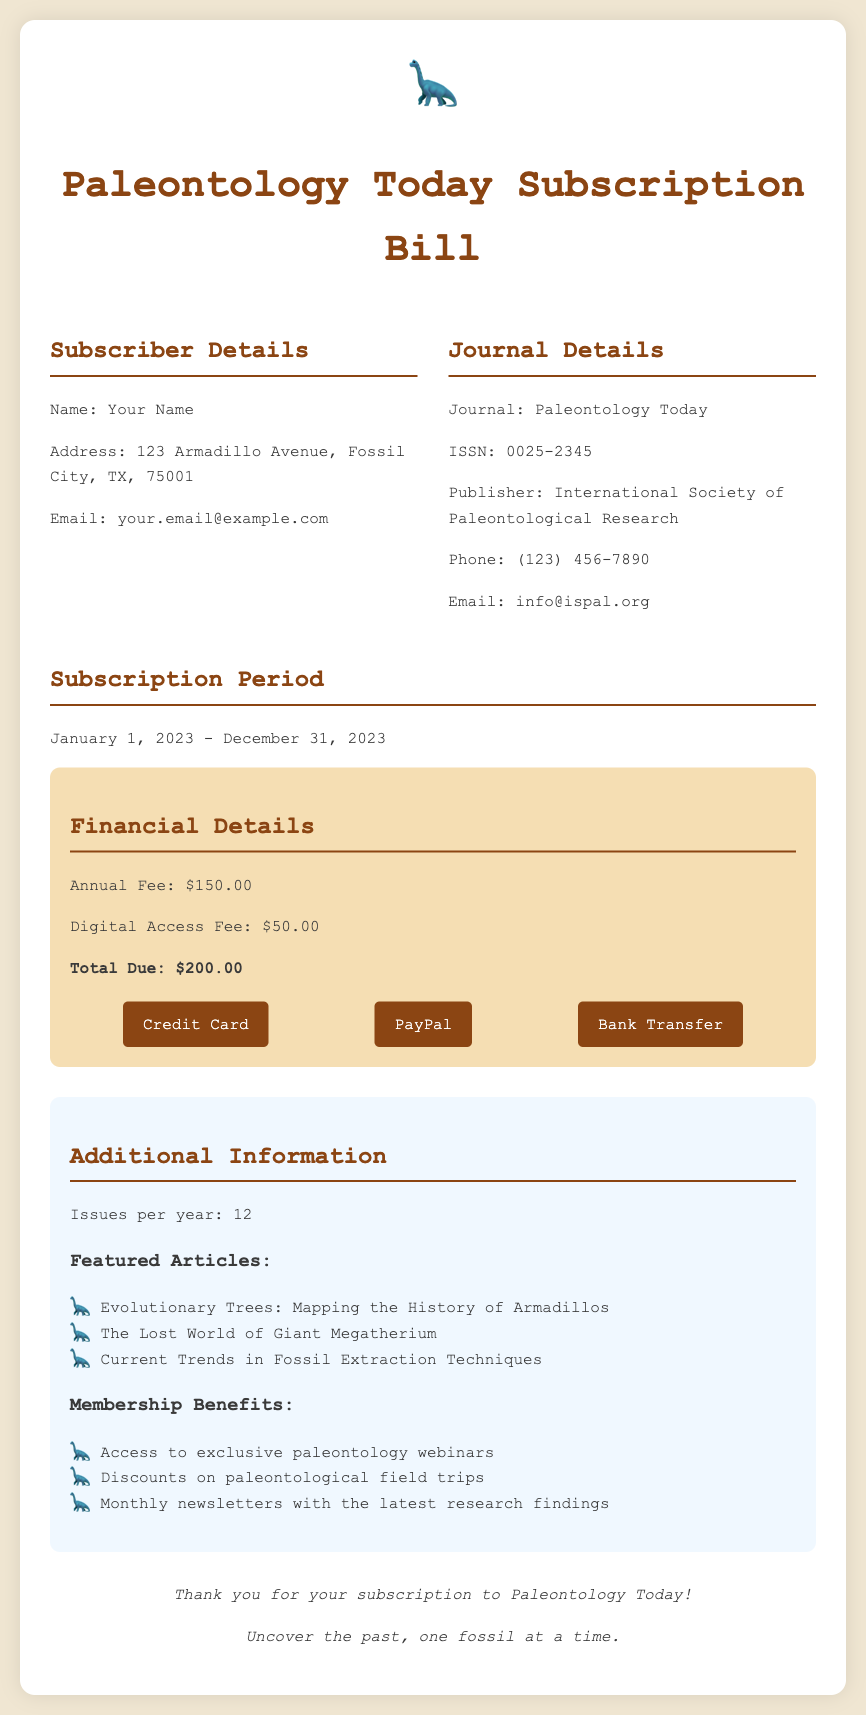What is the annual fee? The annual fee is a specific charge mentioned in the financial details section of the document.
Answer: $150.00 What is the digital access fee? The digital access fee is outlined in the financial details and is part of the total due amount.
Answer: $50.00 What is the total due amount? The total due amount is the sum of the annual fee and digital access fee provided in the financial details.
Answer: $200.00 How many issues are published per year? The number of issues per year is specified under the additional information section of the document.
Answer: 12 What are the dates for the subscription period? The subscription period is indicated in a specific section of the document regarding subscription duration.
Answer: January 1, 2023 - December 31, 2023 Which publisher produces the journal? The publisher's name is mentioned alongside the journal details, providing essential information for readers.
Answer: International Society of Paleontological Research What is one of the featured articles? Featured articles are listed in the additional information section, showcasing topics of interest for subscribers.
Answer: Evolutionary Trees: Mapping the History of Armadillos What type of payment methods are accepted? The payment methods are outlined in the financial details and indicate how subscribers can pay their dues.
Answer: Credit Card, PayPal, Bank Transfer What benefits do members receive? Membership benefits are detailed in the additional information section, offering insights into advantages for subscribers.
Answer: Access to exclusive paleontology webinars, Discounts on paleontological field trips, Monthly newsletters with the latest research findings 